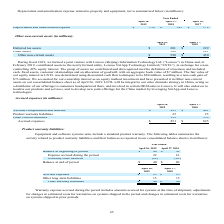From Netapp's financial document, Which years does the table provide information for the company's activity related to product warranty liabilities and their balances as reported in their consolidated balance sheets The document shows two values: 2019 and 2018. From the document: "April 26, 2019 April 27, 2018 April 26, 2019 April 27, 2018..." Also, What was the Balance at beginning of period in 2019? According to the financial document, 40 (in millions). The relevant text states: "Balance at beginning of period $ 40 $ 50..." Also, What was the Expense accrued during the period in 2018? According to the financial document, 16 (in millions). The relevant text states: "Expense accrued during the period 22 16..." Also, can you calculate: What was the change in expense accrued during the period between 2018 and 2019? Based on the calculation: 22-16, the result is 6 (in millions). This is based on the information: "Expense accrued during the period 22 16 Expense accrued during the period 22 16..." The key data points involved are: 16, 22. Also, How many years did the balance at beginning of period exceed $45 million? Based on the analysis, there are 1 instances. The counting process: 2018. Also, can you calculate: What was the percentage change in the Warranty costs incurred between 2018 and 2019? To answer this question, I need to perform calculations using the financial data. The calculation is: (-22-(-26))/-26, which equals -15.38 (percentage). This is based on the information: "Deferred tax assets $ 201 $ 229 April 26,..." The key data points involved are: 22, 26. 